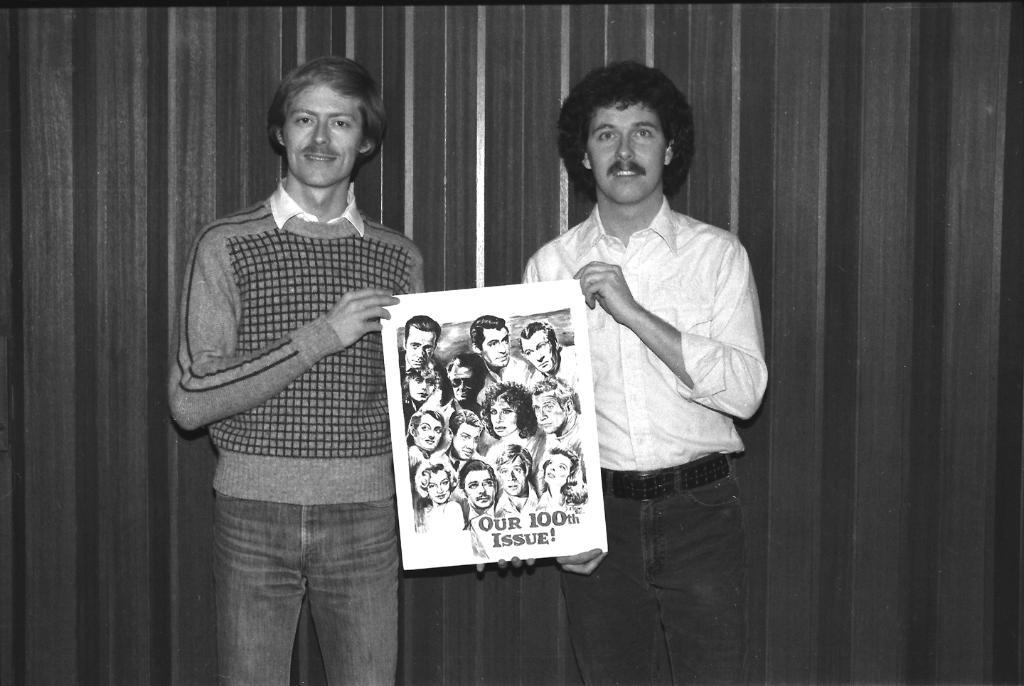How many people are in the image? There are two people in the image. What are the two people doing in the image? The two people are holding a poster. What is depicted on the poster they are holding? The poster contains pictures of people. Is there any text on the poster? Yes, there is text on the poster. What is the weight of the operation depicted on the poster? There is no operation depicted on the poster, and therefore no weight can be determined. 